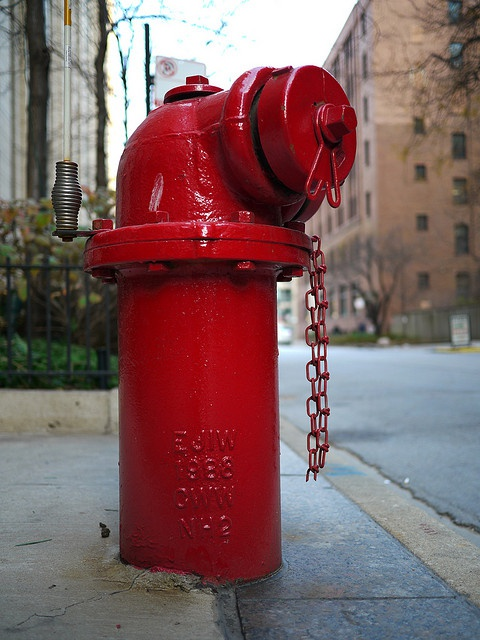Describe the objects in this image and their specific colors. I can see a fire hydrant in teal, maroon, black, and gray tones in this image. 